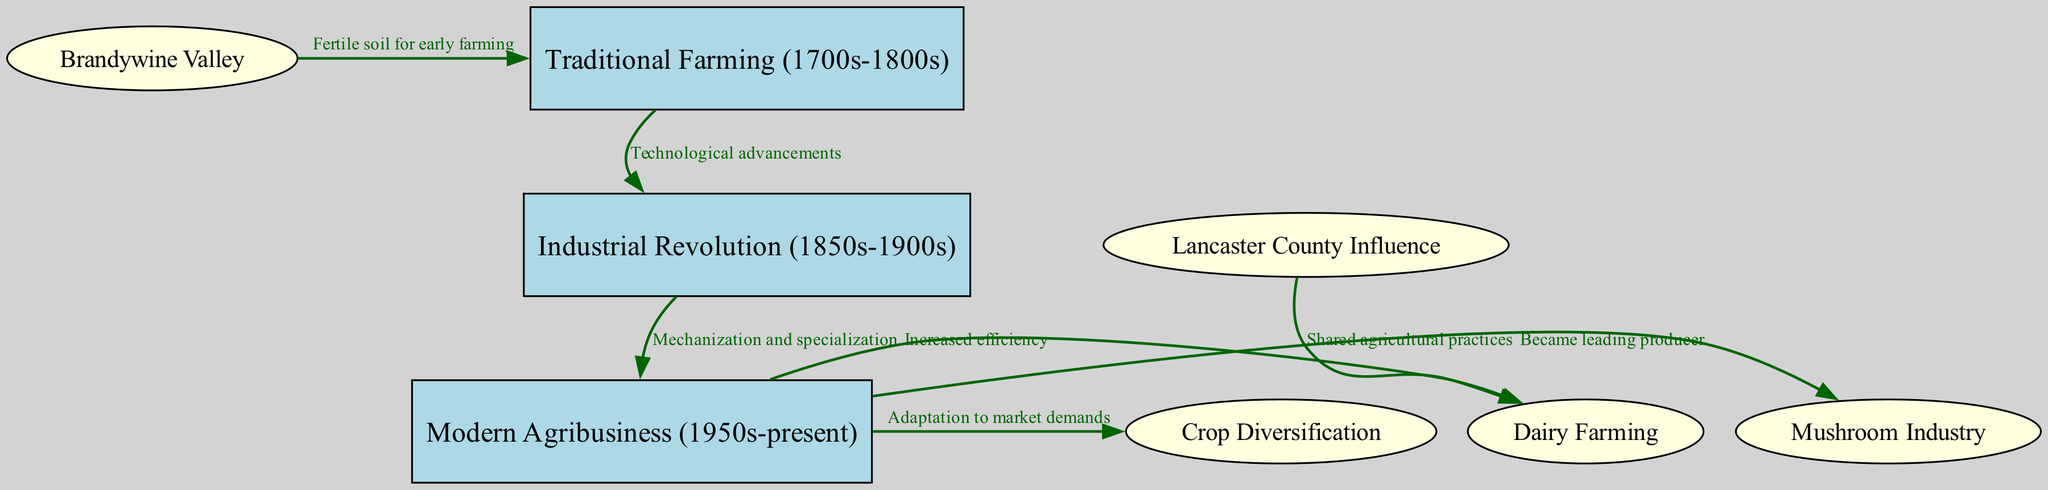What period does the Traditional Farming encompass? The Traditional Farming node specifically indicates the timeframe of the 1700s to 1800s, as described in the label of that node.
Answer: 1700s-1800s How many nodes are there in the diagram? By counting all nodes provided in the data, we determine there are eight nodes labeled from 1 to 8, including various forms of agriculture and historical influences.
Answer: 8 What is the relationship between the Industrial Revolution and Modern Agribusiness? The edge connecting these two nodes specifies that the relationship is characterized by "Mechanization and specialization," indicating that these advancements in agriculture emerged as a result of the Industrial Revolution.
Answer: Mechanization and specialization Which industry became the leading producer during the Modern Agribusiness phase? The connection from Modern Agribusiness to the Mushroom Industry node indicates that it became the leading producer during this time, as per the edge label.
Answer: Mushroom Industry What effect did Lancaster County have on Dairy Farming? The link from Lancaster County Influence to Dairy Farming conveys that they had "Shared agricultural practices," which influence the way dairy farming was conducted in Chester County.
Answer: Shared agricultural practices How does Crop Diversification relate to Modern Agribusiness? The edge from Modern Agribusiness to Crop Diversification states "Adaptation to market demands," emphasizing that diversifying crops is a strategy employed in response to market needs within the context of modern agricultural practices.
Answer: Adaptation to market demands In which area was the fertile soil beneficial for early farming? The diagram indicates that the Brandywine Valley, connected to Traditional Farming, had fertile soil that benefitted early farming practices, as described in the edge.
Answer: Brandywine Valley What technological progression led from Traditional Farming to the Industrial Revolution? The edge from the Traditional Farming node to the Industrial Revolution one signifies that "Technological advancements" were the driving factors for this transition.
Answer: Technological advancements 